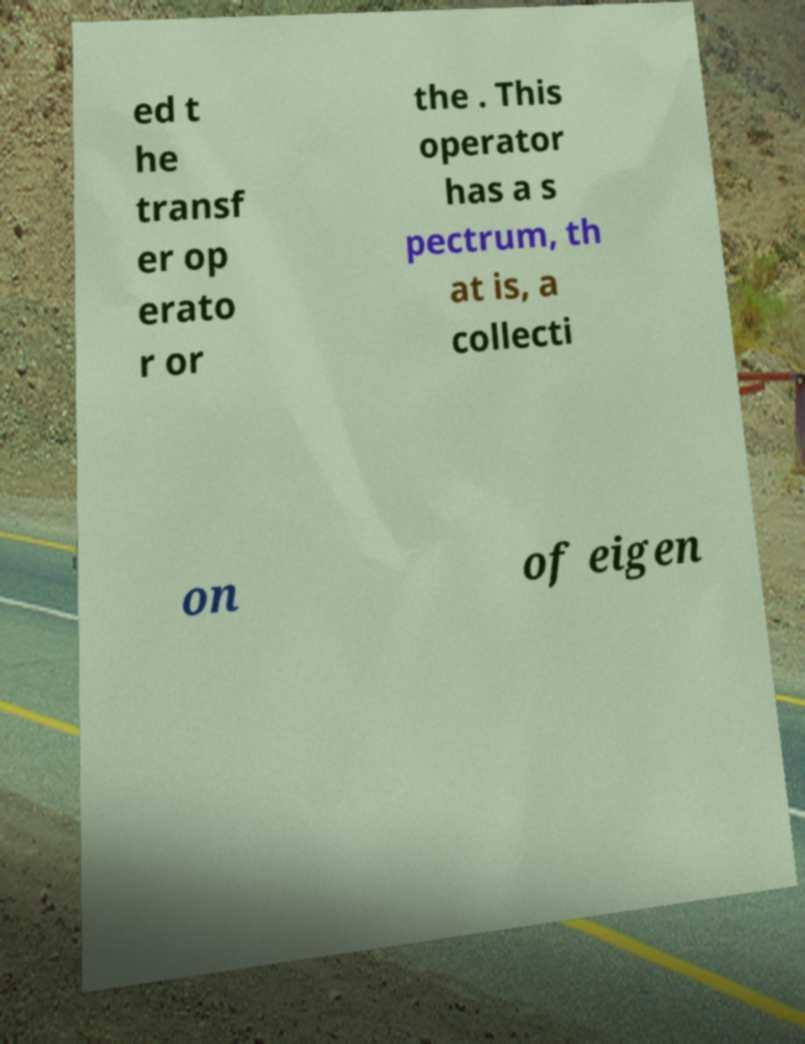Please identify and transcribe the text found in this image. ed t he transf er op erato r or the . This operator has a s pectrum, th at is, a collecti on of eigen 